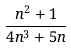Convert formula to latex. <formula><loc_0><loc_0><loc_500><loc_500>\frac { n ^ { 2 } + 1 } { 4 n ^ { 3 } + 5 n }</formula> 